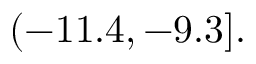Convert formula to latex. <formula><loc_0><loc_0><loc_500><loc_500>( - 1 1 . 4 , - 9 . 3 ] .</formula> 